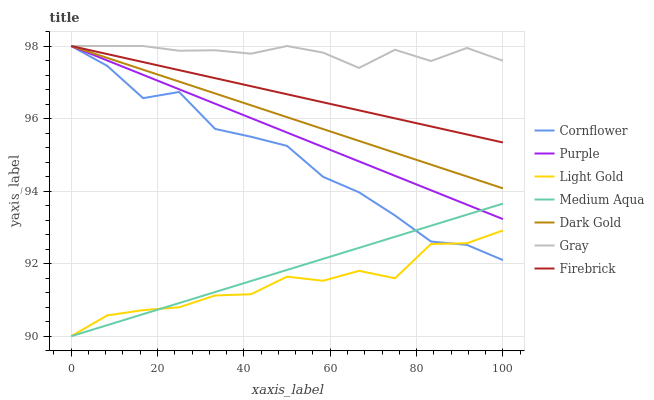Does Light Gold have the minimum area under the curve?
Answer yes or no. Yes. Does Gray have the maximum area under the curve?
Answer yes or no. Yes. Does Purple have the minimum area under the curve?
Answer yes or no. No. Does Purple have the maximum area under the curve?
Answer yes or no. No. Is Medium Aqua the smoothest?
Answer yes or no. Yes. Is Cornflower the roughest?
Answer yes or no. Yes. Is Gray the smoothest?
Answer yes or no. No. Is Gray the roughest?
Answer yes or no. No. Does Medium Aqua have the lowest value?
Answer yes or no. Yes. Does Purple have the lowest value?
Answer yes or no. No. Does Dark Gold have the highest value?
Answer yes or no. Yes. Does Medium Aqua have the highest value?
Answer yes or no. No. Is Light Gold less than Firebrick?
Answer yes or no. Yes. Is Purple greater than Light Gold?
Answer yes or no. Yes. Does Gray intersect Dark Gold?
Answer yes or no. Yes. Is Gray less than Dark Gold?
Answer yes or no. No. Is Gray greater than Dark Gold?
Answer yes or no. No. Does Light Gold intersect Firebrick?
Answer yes or no. No. 